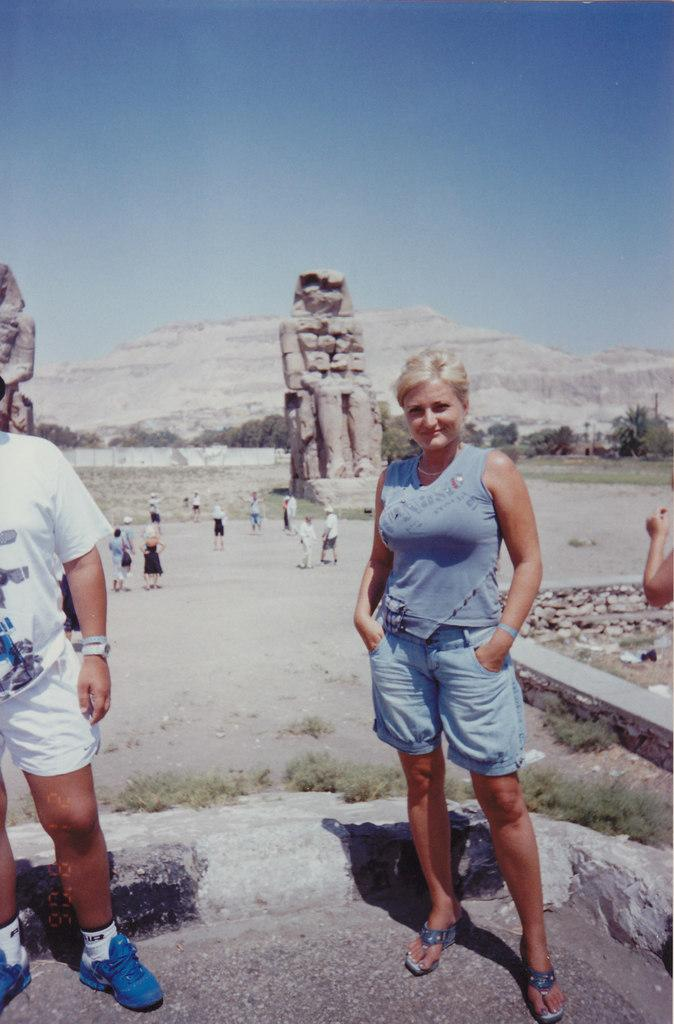How many people are there are people in the image? There is a woman and a man standing in the image, along with a group of people, making a total of at least three people. What is the ground like in the image? The ground is visible in the image, and there is grass present. What can be seen in the sky in the image? The sky is visible in the image. What type of creature is the lawyer holding in the image? There is no lawyer or creature present in the image. 